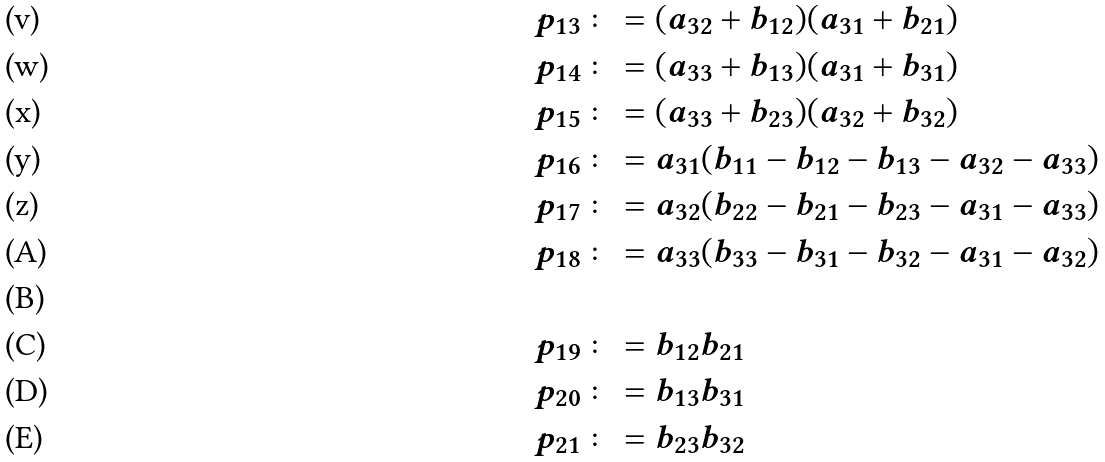Convert formula to latex. <formula><loc_0><loc_0><loc_500><loc_500>p _ { 1 3 } & \colon = ( a _ { 3 2 } + b _ { 1 2 } ) ( a _ { 3 1 } + b _ { 2 1 } ) \\ p _ { 1 4 } & \colon = ( a _ { 3 3 } + b _ { 1 3 } ) ( a _ { 3 1 } + b _ { 3 1 } ) \\ p _ { 1 5 } & \colon = ( a _ { 3 3 } + b _ { 2 3 } ) ( a _ { 3 2 } + b _ { 3 2 } ) \\ p _ { 1 6 } & \colon = a _ { 3 1 } ( b _ { 1 1 } - b _ { 1 2 } - b _ { 1 3 } - a _ { 3 2 } - a _ { 3 3 } ) \\ p _ { 1 7 } & \colon = a _ { 3 2 } ( b _ { 2 2 } - b _ { 2 1 } - b _ { 2 3 } - a _ { 3 1 } - a _ { 3 3 } ) \\ p _ { 1 8 } & \colon = a _ { 3 3 } ( b _ { 3 3 } - b _ { 3 1 } - b _ { 3 2 } - a _ { 3 1 } - a _ { 3 2 } ) \\ \\ p _ { 1 9 } & \colon = b _ { 1 2 } b _ { 2 1 } \\ p _ { 2 0 } & \colon = b _ { 1 3 } b _ { 3 1 } \\ p _ { 2 1 } & \colon = b _ { 2 3 } b _ { 3 2 }</formula> 